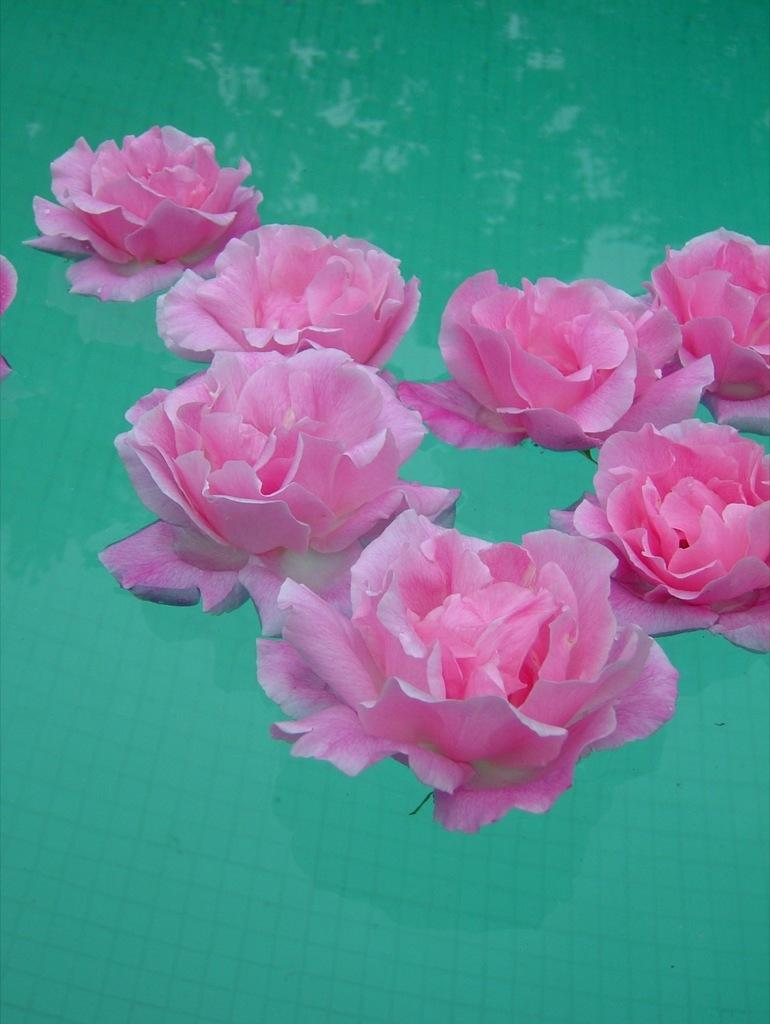What type of flora is present in the image? There are flowers in the image. What color are the flowers? The flowers are pink in color. Where are the flowers located in the image? The flowers are on the surface of the water. What color is the water in the image? The water is green in color. What type of mine can be seen in the image? There is no mine present in the image; it features flowers on the surface of green water. 